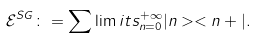Convert formula to latex. <formula><loc_0><loc_0><loc_500><loc_500>\mathcal { E } ^ { S G } \colon = \sum \lim i t s _ { n = 0 } ^ { + \infty } | n > < n + | .</formula> 